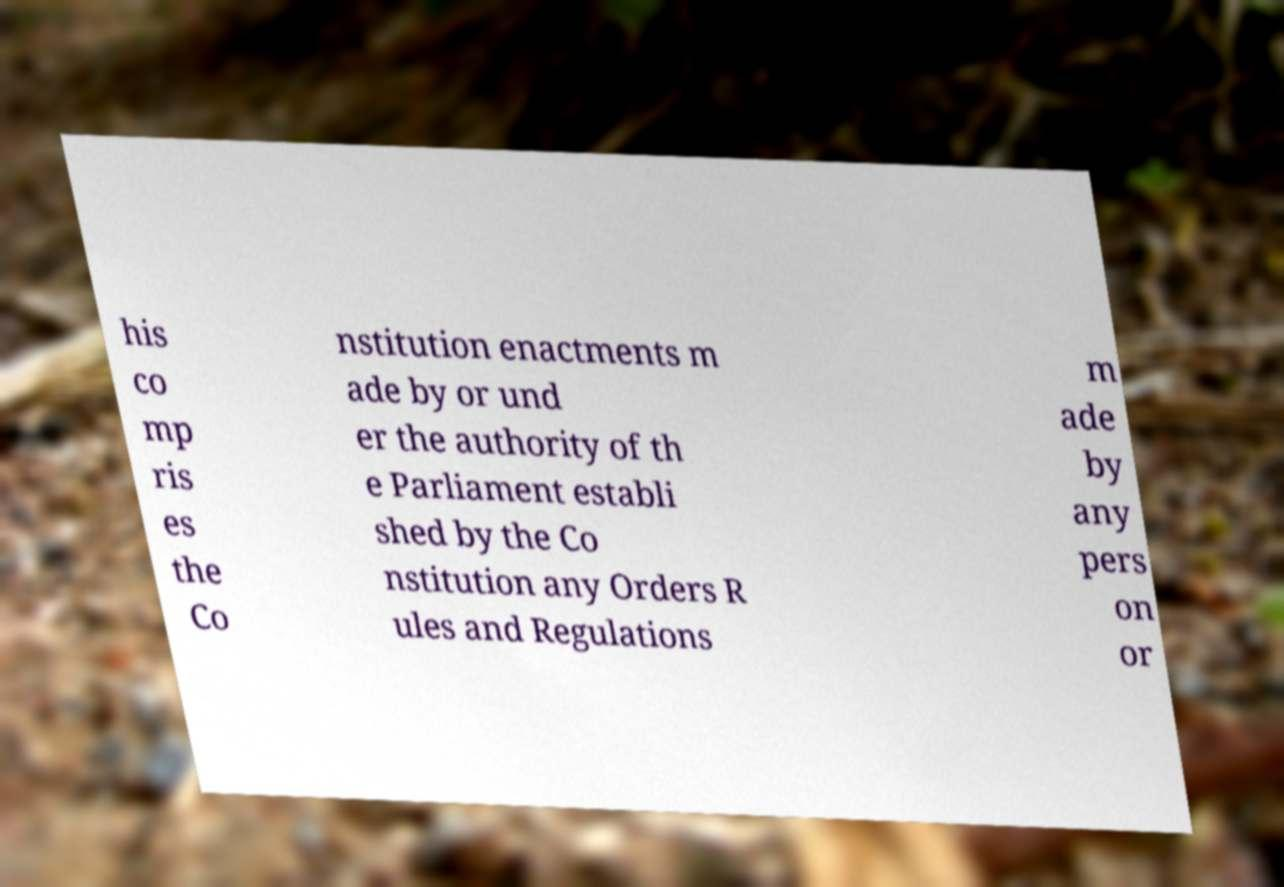Could you extract and type out the text from this image? his co mp ris es the Co nstitution enactments m ade by or und er the authority of th e Parliament establi shed by the Co nstitution any Orders R ules and Regulations m ade by any pers on or 